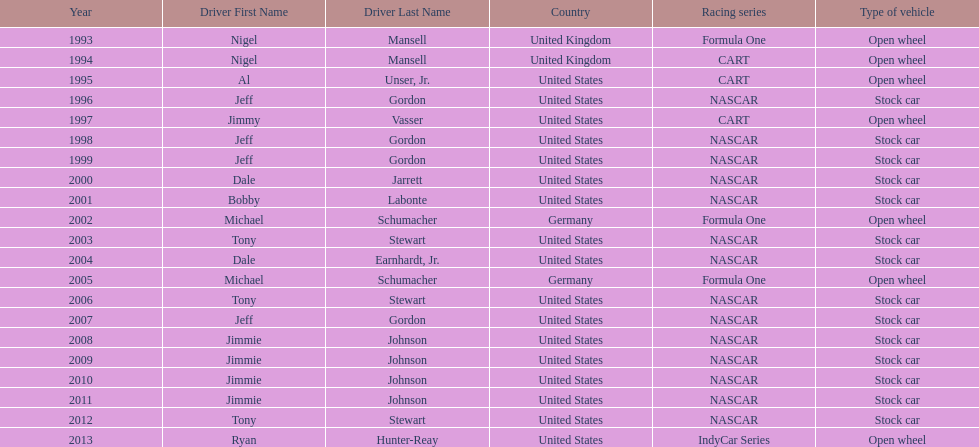Which driver won espy awards 11 years apart from each other? Jeff Gordon. Could you parse the entire table as a dict? {'header': ['Year', 'Driver First Name', 'Driver Last Name', 'Country', 'Racing series', 'Type of vehicle'], 'rows': [['1993', 'Nigel', 'Mansell', 'United Kingdom', 'Formula One', 'Open wheel'], ['1994', 'Nigel', 'Mansell', 'United Kingdom', 'CART', 'Open wheel'], ['1995', 'Al', 'Unser, Jr.', 'United States', 'CART', 'Open wheel'], ['1996', 'Jeff', 'Gordon', 'United States', 'NASCAR', 'Stock car'], ['1997', 'Jimmy', 'Vasser', 'United States', 'CART', 'Open wheel'], ['1998', 'Jeff', 'Gordon', 'United States', 'NASCAR', 'Stock car'], ['1999', 'Jeff', 'Gordon', 'United States', 'NASCAR', 'Stock car'], ['2000', 'Dale', 'Jarrett', 'United States', 'NASCAR', 'Stock car'], ['2001', 'Bobby', 'Labonte', 'United States', 'NASCAR', 'Stock car'], ['2002', 'Michael', 'Schumacher', 'Germany', 'Formula One', 'Open wheel'], ['2003', 'Tony', 'Stewart', 'United States', 'NASCAR', 'Stock car'], ['2004', 'Dale', 'Earnhardt, Jr.', 'United States', 'NASCAR', 'Stock car'], ['2005', 'Michael', 'Schumacher', 'Germany', 'Formula One', 'Open wheel'], ['2006', 'Tony', 'Stewart', 'United States', 'NASCAR', 'Stock car'], ['2007', 'Jeff', 'Gordon', 'United States', 'NASCAR', 'Stock car'], ['2008', 'Jimmie', 'Johnson', 'United States', 'NASCAR', 'Stock car'], ['2009', 'Jimmie', 'Johnson', 'United States', 'NASCAR', 'Stock car'], ['2010', 'Jimmie', 'Johnson', 'United States', 'NASCAR', 'Stock car'], ['2011', 'Jimmie', 'Johnson', 'United States', 'NASCAR', 'Stock car'], ['2012', 'Tony', 'Stewart', 'United States', 'NASCAR', 'Stock car'], ['2013', 'Ryan', 'Hunter-Reay', 'United States', 'IndyCar Series', 'Open wheel']]} 